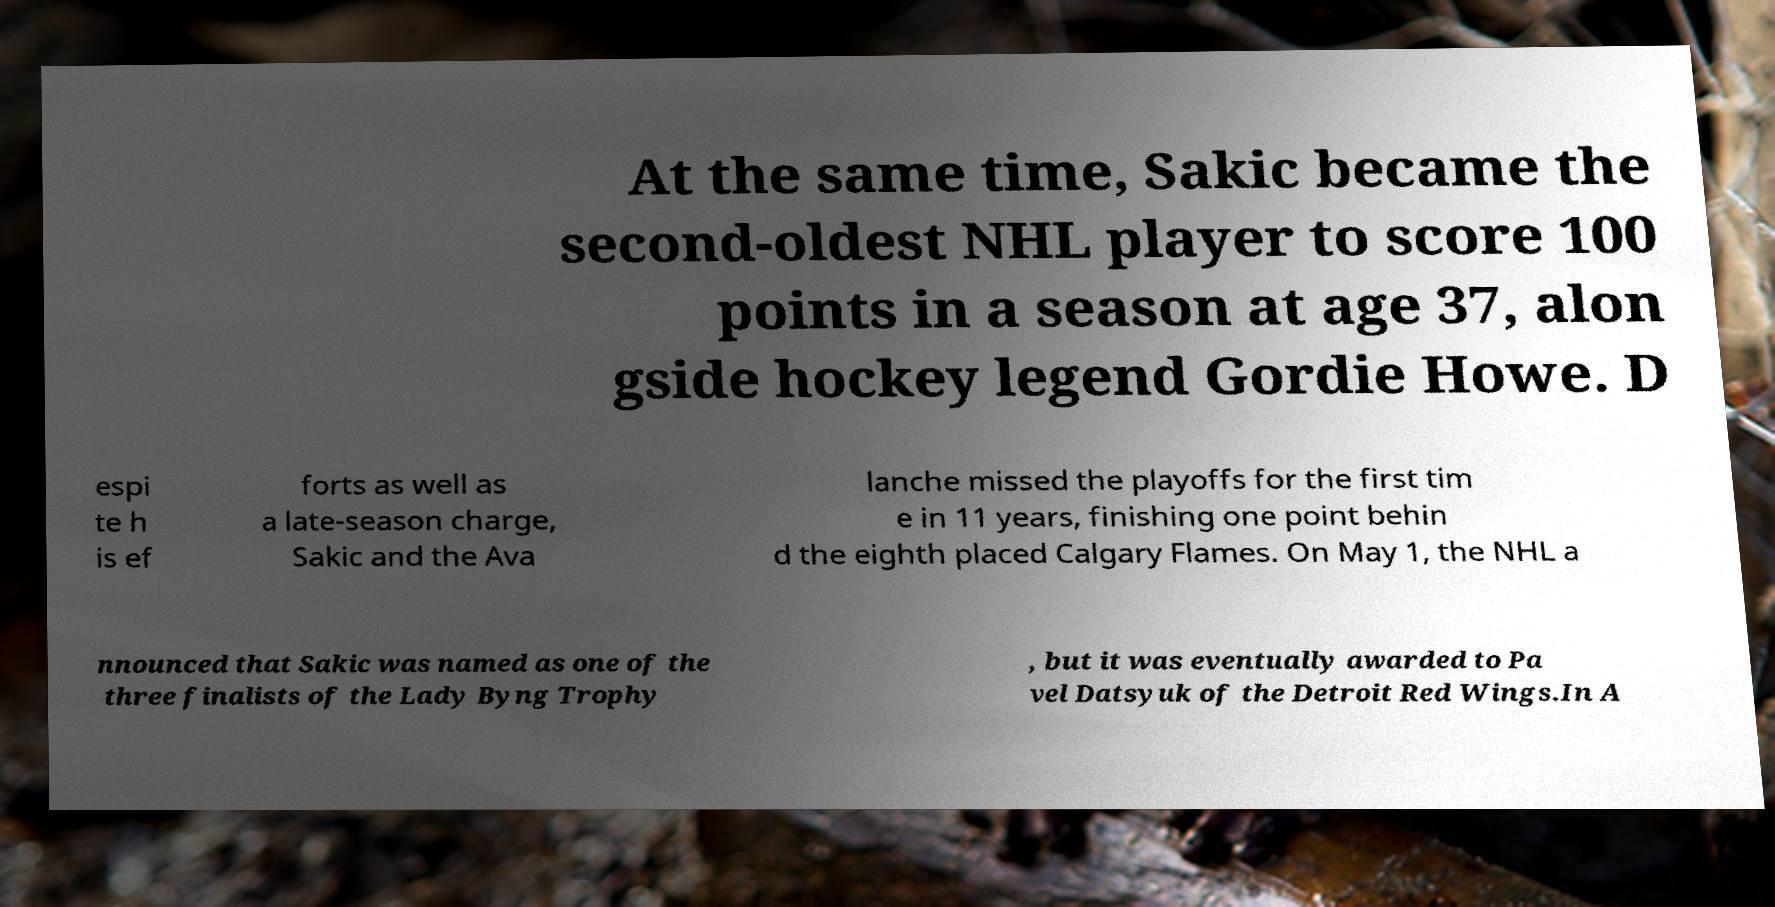What messages or text are displayed in this image? I need them in a readable, typed format. At the same time, Sakic became the second-oldest NHL player to score 100 points in a season at age 37, alon gside hockey legend Gordie Howe. D espi te h is ef forts as well as a late-season charge, Sakic and the Ava lanche missed the playoffs for the first tim e in 11 years, finishing one point behin d the eighth placed Calgary Flames. On May 1, the NHL a nnounced that Sakic was named as one of the three finalists of the Lady Byng Trophy , but it was eventually awarded to Pa vel Datsyuk of the Detroit Red Wings.In A 